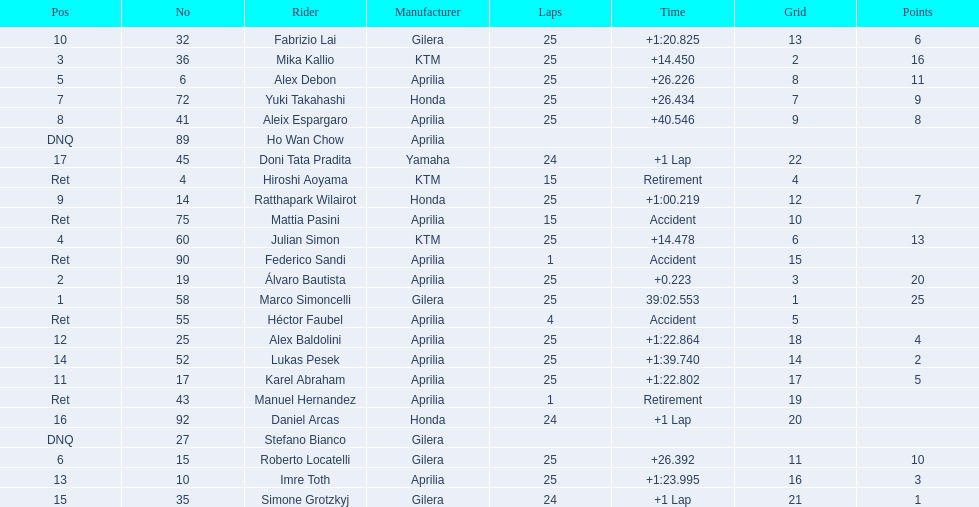What was the fastest overall time? 39:02.553. Who does this time belong to? Marco Simoncelli. 